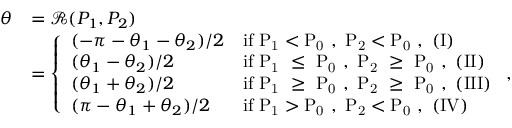Convert formula to latex. <formula><loc_0><loc_0><loc_500><loc_500>\begin{array} { r l } { \theta } & { = \mathcal { R } ( P _ { 1 } , P _ { 2 } ) } \\ & { = \left \{ \begin{array} { l l } { ( - \pi - \theta _ { 1 } - \theta _ { 2 } ) / 2 } & { i f P _ { 1 } < P _ { 0 } , P _ { 2 } < P _ { 0 } , ( I ) } \\ { ( \theta _ { 1 } - \theta _ { 2 } ) / 2 } & { i f P _ { 1 } \leq P _ { 0 } , P _ { 2 } \geq P _ { 0 } , ( I I ) } \\ { ( \theta _ { 1 } + \theta _ { 2 } ) / 2 } & { i f P _ { 1 } \geq P _ { 0 } , P _ { 2 } \geq P _ { 0 } , ( I I I ) } \\ { ( \pi - \theta _ { 1 } + \theta _ { 2 } ) / 2 } & { i f P _ { 1 } > P _ { 0 } , P _ { 2 } < P _ { 0 } , ( I V ) } \end{array} , } \end{array}</formula> 